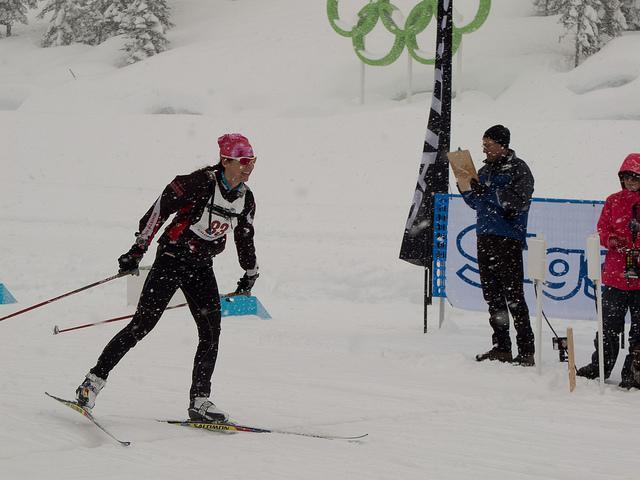How many people are in the scene?
Give a very brief answer. 3. How many skiers are there?
Give a very brief answer. 1. How many men are in the picture?
Give a very brief answer. 2. How many people are there?
Give a very brief answer. 3. 